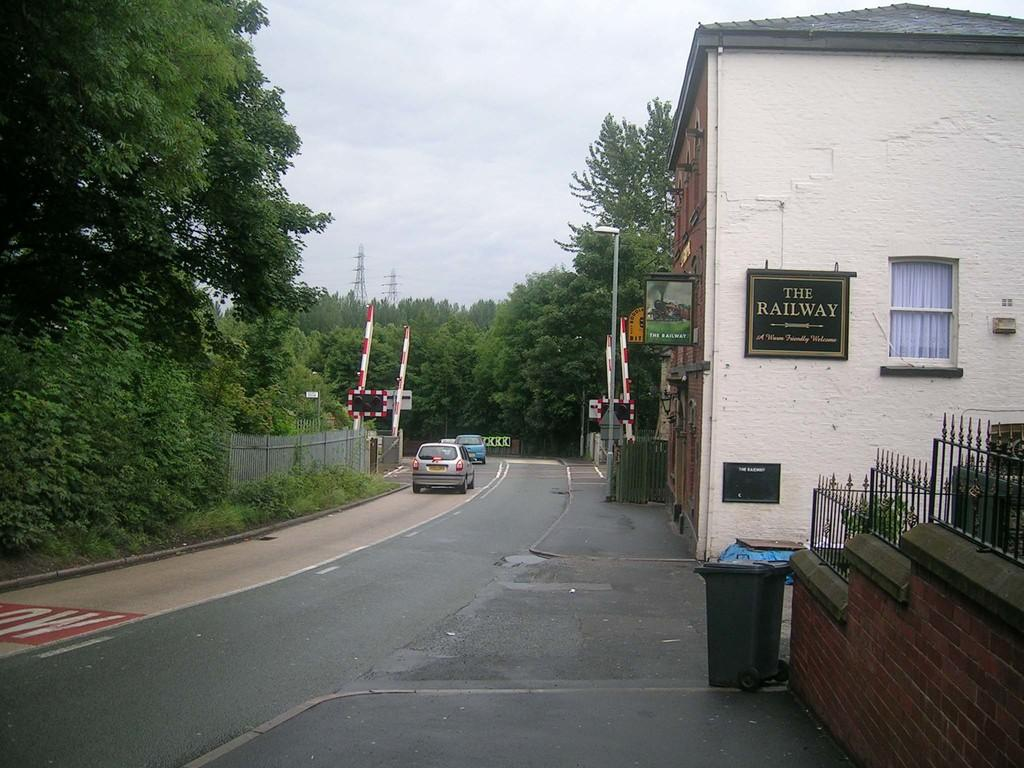Provide a one-sentence caption for the provided image. A warm friendly welcome from the Railway located off the street. 